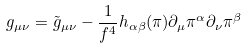<formula> <loc_0><loc_0><loc_500><loc_500>g _ { \mu \nu } = \tilde { g } _ { \mu \nu } - \frac { 1 } { f ^ { 4 } } h _ { \alpha \beta } ( \pi ) \partial _ { \mu } \pi ^ { \alpha } \partial _ { \nu } \pi ^ { \beta }</formula> 